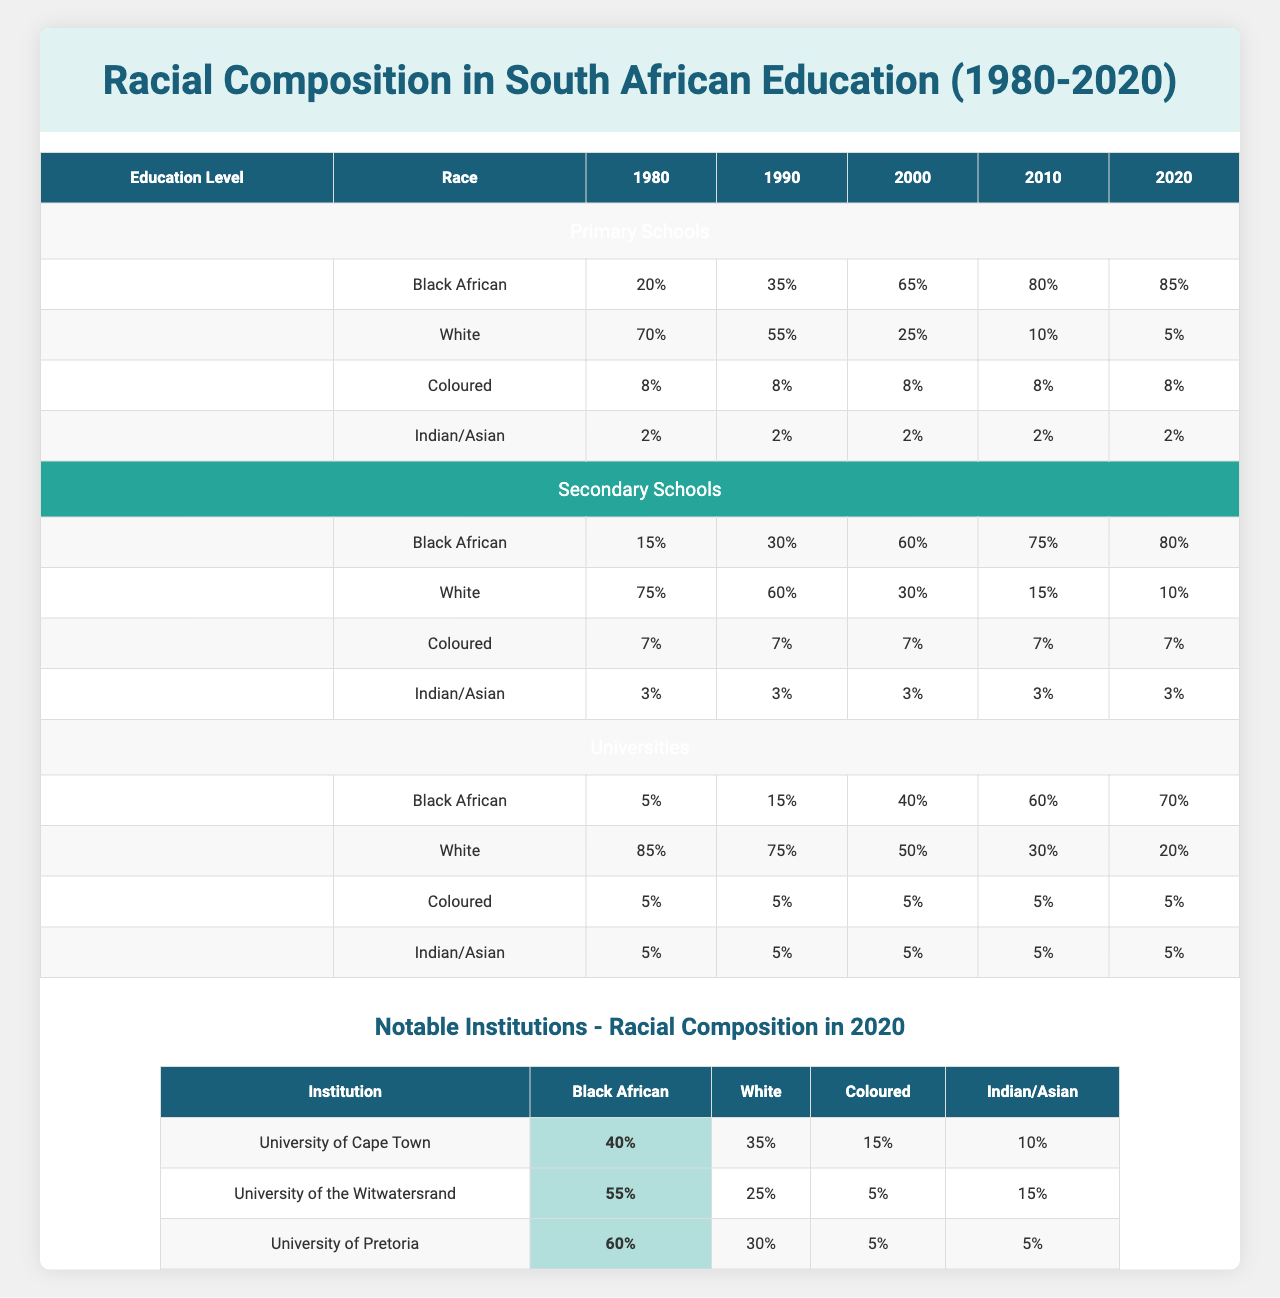What's the percentage of Black African students in primary schools in 1990? In the table, under the 'Primary Schools' section for the year 1990, the percentage of Black African students is listed as 35%.
Answer: 35% What was the racial composition of White students in universities in 2010? For the 'Universities' section in the year 2010, the percentage of White students is shown as 30%.
Answer: 30% How much did the percentage of Black African students in secondary schools change from 1980 to 2020? The percentage in 1980 was 15%, and in 2020 it was 80%. Therefore, the change is calculated as 80% - 15% = 65%.
Answer: 65% Which education level saw the largest increase in Black African student percentages from 1980 to 2020? Analyzing the data, primary schools increased from 20% to 85%, secondary schools from 15% to 80%, and universities from 5% to 70%. The largest increase is in primary schools, which changed by 65%.
Answer: Primary Schools What is the total percentage of Coloured students across all educational levels in 2020? Coloured students have the following percentages for 2020: Primary Schools 8%, Secondary Schools 7%, and Universities 5%. The total is 8% + 7% + 5% = 20%.
Answer: 20% Did the percentage of White students in secondary schools decrease from 1990 to 2020? In 1990, the percentage of White students was 60%, and in 2020 it is 10%. Since 10% is less than 60%, it confirms that there was a decrease.
Answer: Yes What is the average percentage of Indian/Asian students across all levels in 2020? Looking at the percentages for Indian/Asian in 2020: 2% in primary schools, 3% in secondary schools, and 5% in universities, we calculate the average: (2 + 3 + 5) / 3 = 10 / 3 ≈ 3.33%.
Answer: 3.33% How does the racial composition of students at the University of Cape Town in 2020 compare to that of the University of Pretoria? For 2020, UCT has 40% Black African and 35% White, while UP has 60% Black African and 30% White. UCT has a lower percentage of Black African students, while UP has a lower percentage of White students.
Answer: UCT has fewer Black African students; UP has fewer White students Which education level has the most even distribution of racial composition in 2020? Examining the 2020 figures: Primary Schools (8% Coloured, 2% Indian/Asian), Secondary Schools (7% Coloured, 3% Indian/Asian), and Universities (5% Coloured, 5% Indian/Asian; even). Both Universities and Secondary Schools have more equal distributions.
Answer: Tied: Secondary Schools and Universities 